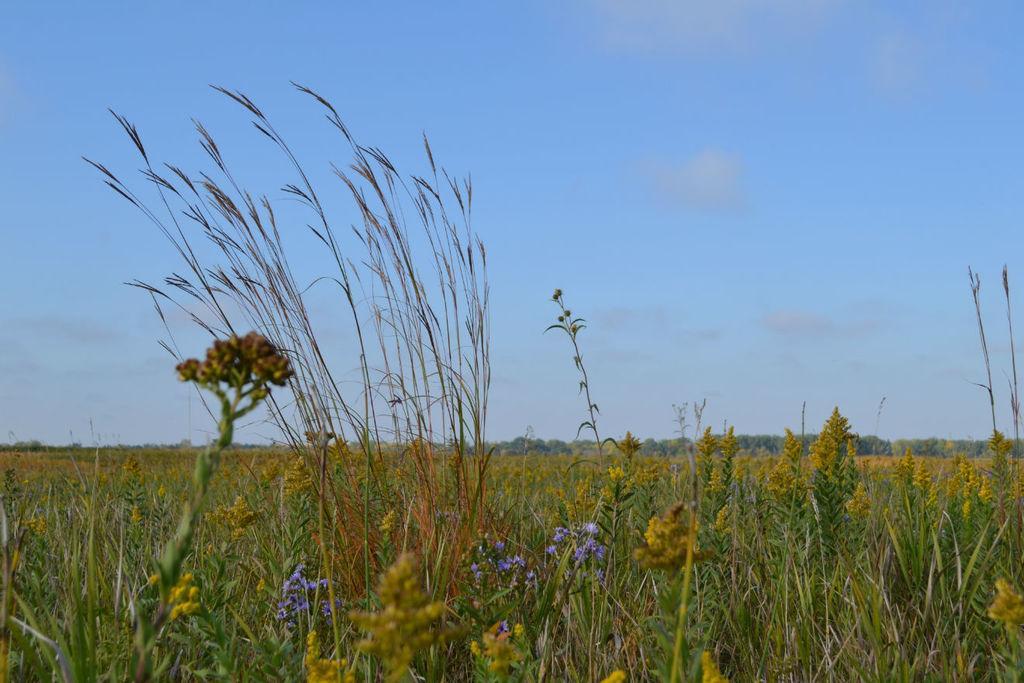Please provide a concise description of this image. In this picture I can see the plants in front and I see few buds and flowers which are of purple color. In the background I can see the sky. 